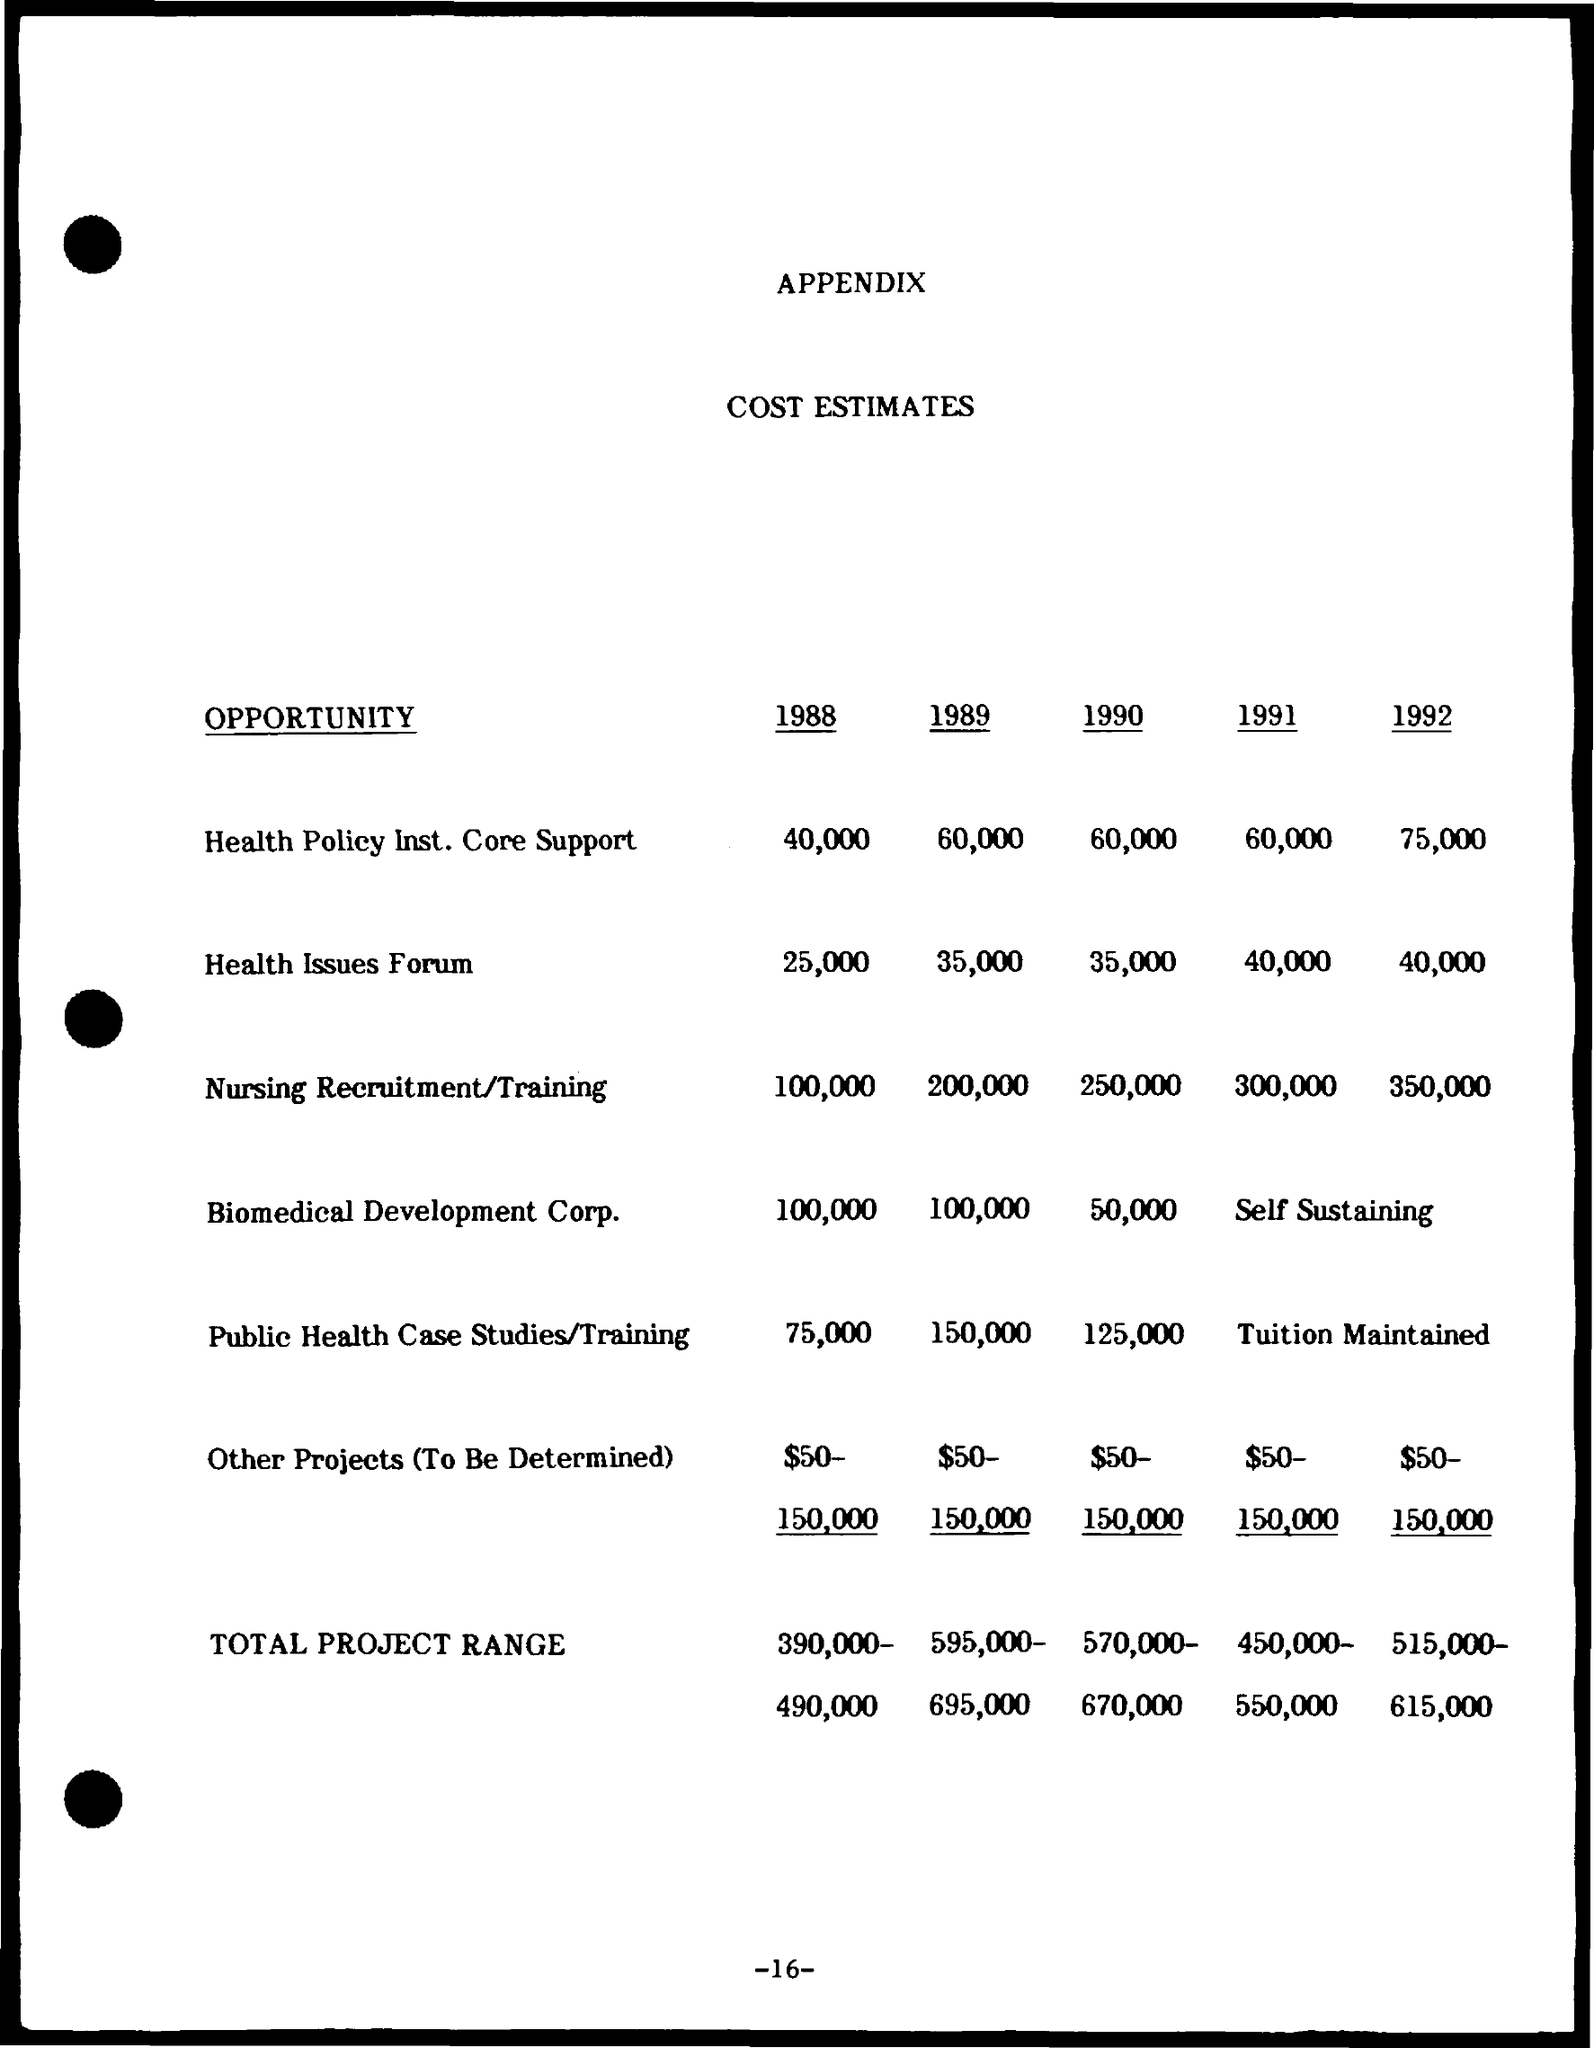What is the cost estimate for Health Policy Ins. Core Support for 1988?
Make the answer very short. 40,000. What is the cost estimate for Health Issues forum for 1988?
Make the answer very short. 25,000. What is the cost estimate for Nursing Recruitment/Training for 1988?
Ensure brevity in your answer.  100,000. What is the cost estimate for Biomedical Development Corp. for 1988?
Provide a succinct answer. 100,000. What is the cost estimate for Public Health case Studies/Training for 1988?
Your answer should be compact. 75,000. What is the cost estimate for Health Policy Ins. Core Support for 1989?
Offer a very short reply. 60,000. What is the cost estimate for Health Issues forum for 1989?
Your answer should be very brief. 35,000. What is the cost estimate for Nursing Recruitment/Training for 1989?
Make the answer very short. 200,000. What is the cost estimate for Biomedical Development Corp. for 1989?
Make the answer very short. 100,000. What is the cost estimate for Public Health case Studies/Training for 1989?
Provide a succinct answer. 150,000. 